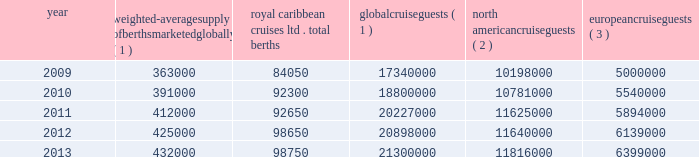Part i the table details the growth in global weighted average berths and the global , north american and european cruise guests over the past five years : weighted-average supply of berths marketed globally ( 1 ) royal caribbean cruises ltd .
Total berths global cruise guests ( 1 ) north american cruise guests ( 2 ) european cruise guests ( 3 ) .
( 1 ) source : our estimates of the number of global cruise guests and the weighted-average supply of berths marketed globally are based on a com- bination of data that we obtain from various publicly available cruise industry trade information sources including seatrade insider , cruise industry news and cruise line international association ( 201cclia 201d ) .
In addition , our estimates incorporate our own statistical analysis utilizing the same publicly available cruise industry data as a base .
( 2 ) source : cruise line international association based on cruise guests carried for at least two consecutive nights for years 2009 through 2012 .
Year 2013 amounts represent our estimates ( see number 1 above ) .
Includes the united states of america and canada .
( 3 ) source : clia europe , formerly european cruise council , for years 2009 through 2012 .
Year 2013 amounts represent our estimates ( see number 1 above ) .
North america the majority of cruise guests are sourced from north america , which represented approximately 56% ( 56 % ) of global cruise guests in 2013 .
The compound annual growth rate in cruise guests sourced from this market was approximately 3.2% ( 3.2 % ) from 2009 to 2013 .
Europe cruise guests sourced from europe represented approximately 30% ( 30 % ) of global cruise guests in 2013 .
The compound annual growth rate in cruise guests sourced from this market was approximately 6.0% ( 6.0 % ) from 2009 to 2013 .
Other markets in addition to expected industry growth in north america and europe , we expect the asia/pacific region to demonstrate an even higher growth rate in the near term , although it will continue to represent a relatively small sector compared to north america and europe .
Based on industry data , cruise guests sourced from the asia/pacific region represented approximately 4.5% ( 4.5 % ) of global cruise guests in 2013 .
The compound annual growth rate in cruise guests sourced from this market was approximately 15% ( 15 % ) from 2011 to 2013 .
Competition we compete with a number of cruise lines .
Our princi- pal competitors are carnival corporation & plc , which owns , among others , aida cruises , carnival cruise lines , costa cruises , cunard line , holland america line , iberocruceros , p&o cruises and princess cruises ; disney cruise line ; msc cruises ; norwegian cruise line and oceania cruises .
Cruise lines compete with other vacation alternatives such as land-based resort hotels and sightseeing destinations for consumers 2019 leisure time .
Demand for such activities is influenced by political and general economic conditions .
Com- panies within the vacation market are dependent on consumer discretionary spending .
Operating strategies our principal operating strategies are to : and employees and protect the environment in which our vessels and organization operate , to better serve our global guest base and grow our business , order to enhance our revenues , our brands globally , expenditures and ensure adequate cash and liquid- ity , with the overall goal of maximizing our return on invested capital and long-term shareholder value , ization and maintenance of existing ships and the transfer of key innovations across each brand , while prudently expanding our fleet with new state-of- the-art cruise ships , ships by deploying them into those markets and itineraries that provide opportunities to optimize returns , while continuing our focus on existing key markets , service customer preferences and expectations in an innovative manner , while supporting our strategic focus on profitability , and .
In 2013 , what percentage of global berths came from royal caribbean? 
Computations: ((98750 / 432000) * 100)
Answer: 22.8588. 